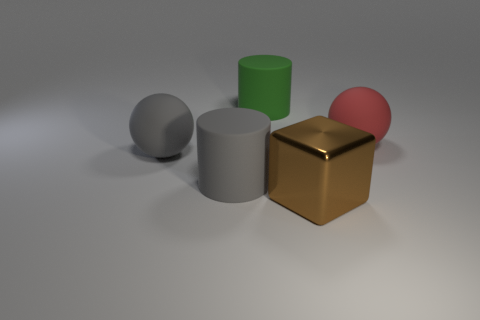Is the number of big balls greater than the number of red matte things?
Ensure brevity in your answer.  Yes. What number of tiny objects are green cylinders or blue balls?
Give a very brief answer. 0. What number of other big spheres are the same material as the red ball?
Give a very brief answer. 1. There is a big matte sphere on the right side of the big gray ball; does it have the same color as the big shiny cube?
Offer a terse response. No. What number of green things are either cylinders or large blocks?
Your response must be concise. 1. Are there any other things that are the same material as the large green cylinder?
Provide a succinct answer. Yes. Is the material of the ball that is to the right of the cube the same as the gray cylinder?
Offer a very short reply. Yes. What number of things are either big gray matte spheres or rubber spheres that are right of the gray sphere?
Your answer should be compact. 2. There is a cylinder that is in front of the rubber thing that is on the right side of the big green rubber cylinder; what number of big blocks are to the right of it?
Offer a very short reply. 1. Do the large object on the right side of the large cube and the green thing have the same shape?
Your response must be concise. No. 